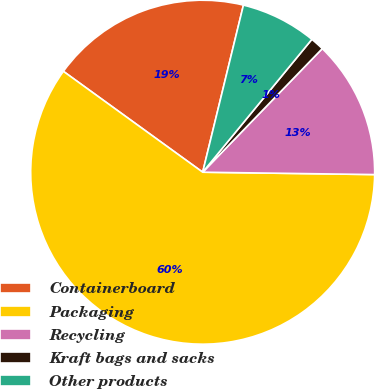Convert chart to OTSL. <chart><loc_0><loc_0><loc_500><loc_500><pie_chart><fcel>Containerboard<fcel>Packaging<fcel>Recycling<fcel>Kraft bags and sacks<fcel>Other products<nl><fcel>18.83%<fcel>59.75%<fcel>12.98%<fcel>1.29%<fcel>7.14%<nl></chart> 